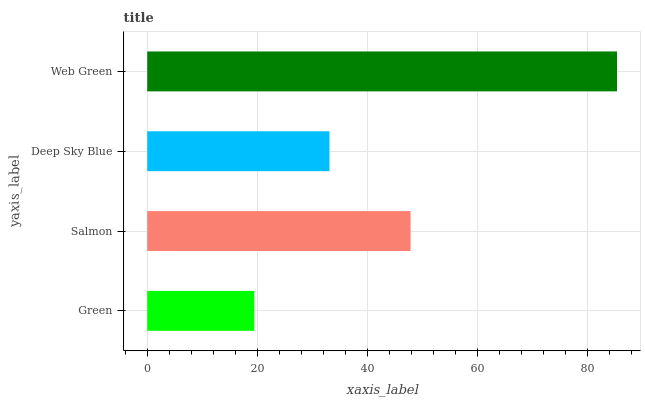Is Green the minimum?
Answer yes or no. Yes. Is Web Green the maximum?
Answer yes or no. Yes. Is Salmon the minimum?
Answer yes or no. No. Is Salmon the maximum?
Answer yes or no. No. Is Salmon greater than Green?
Answer yes or no. Yes. Is Green less than Salmon?
Answer yes or no. Yes. Is Green greater than Salmon?
Answer yes or no. No. Is Salmon less than Green?
Answer yes or no. No. Is Salmon the high median?
Answer yes or no. Yes. Is Deep Sky Blue the low median?
Answer yes or no. Yes. Is Green the high median?
Answer yes or no. No. Is Salmon the low median?
Answer yes or no. No. 